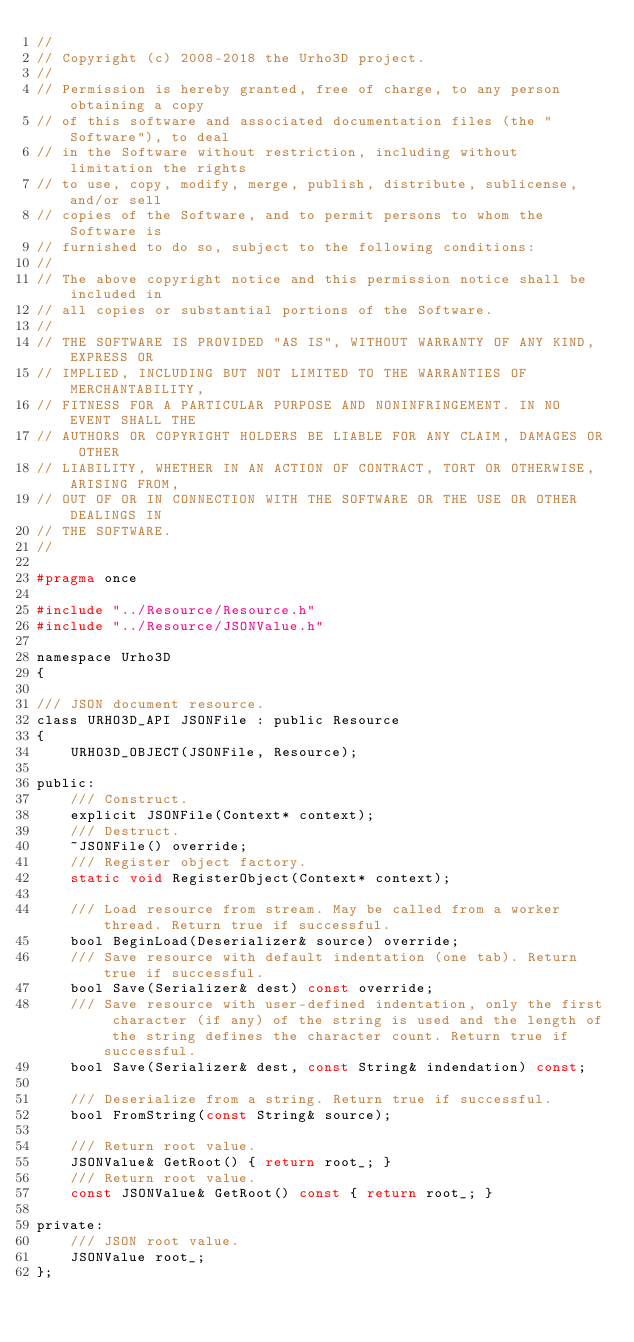<code> <loc_0><loc_0><loc_500><loc_500><_C_>//
// Copyright (c) 2008-2018 the Urho3D project.
//
// Permission is hereby granted, free of charge, to any person obtaining a copy
// of this software and associated documentation files (the "Software"), to deal
// in the Software without restriction, including without limitation the rights
// to use, copy, modify, merge, publish, distribute, sublicense, and/or sell
// copies of the Software, and to permit persons to whom the Software is
// furnished to do so, subject to the following conditions:
//
// The above copyright notice and this permission notice shall be included in
// all copies or substantial portions of the Software.
//
// THE SOFTWARE IS PROVIDED "AS IS", WITHOUT WARRANTY OF ANY KIND, EXPRESS OR
// IMPLIED, INCLUDING BUT NOT LIMITED TO THE WARRANTIES OF MERCHANTABILITY,
// FITNESS FOR A PARTICULAR PURPOSE AND NONINFRINGEMENT. IN NO EVENT SHALL THE
// AUTHORS OR COPYRIGHT HOLDERS BE LIABLE FOR ANY CLAIM, DAMAGES OR OTHER
// LIABILITY, WHETHER IN AN ACTION OF CONTRACT, TORT OR OTHERWISE, ARISING FROM,
// OUT OF OR IN CONNECTION WITH THE SOFTWARE OR THE USE OR OTHER DEALINGS IN
// THE SOFTWARE.
//

#pragma once

#include "../Resource/Resource.h"
#include "../Resource/JSONValue.h"

namespace Urho3D
{

/// JSON document resource.
class URHO3D_API JSONFile : public Resource
{
    URHO3D_OBJECT(JSONFile, Resource);

public:
    /// Construct.
    explicit JSONFile(Context* context);
    /// Destruct.
    ~JSONFile() override;
    /// Register object factory.
    static void RegisterObject(Context* context);

    /// Load resource from stream. May be called from a worker thread. Return true if successful.
    bool BeginLoad(Deserializer& source) override;
    /// Save resource with default indentation (one tab). Return true if successful.
    bool Save(Serializer& dest) const override;
    /// Save resource with user-defined indentation, only the first character (if any) of the string is used and the length of the string defines the character count. Return true if successful.
    bool Save(Serializer& dest, const String& indendation) const;

    /// Deserialize from a string. Return true if successful.
    bool FromString(const String& source);

    /// Return root value.
    JSONValue& GetRoot() { return root_; }
    /// Return root value.
    const JSONValue& GetRoot() const { return root_; }

private:
    /// JSON root value.
    JSONValue root_;
};</code> 